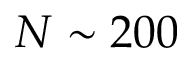Convert formula to latex. <formula><loc_0><loc_0><loc_500><loc_500>N \sim 2 0 0</formula> 